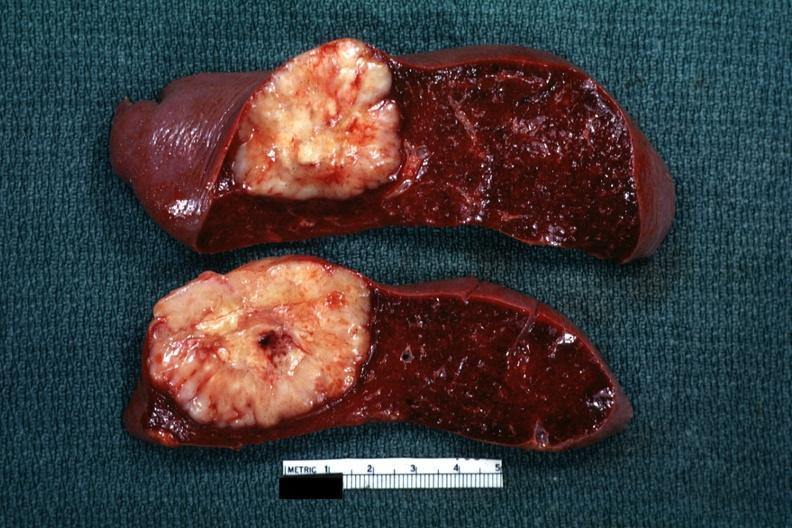s single metastatic appearing lesion quite large diagnosis was reticulum cell sarcoma?
Answer the question using a single word or phrase. Yes 